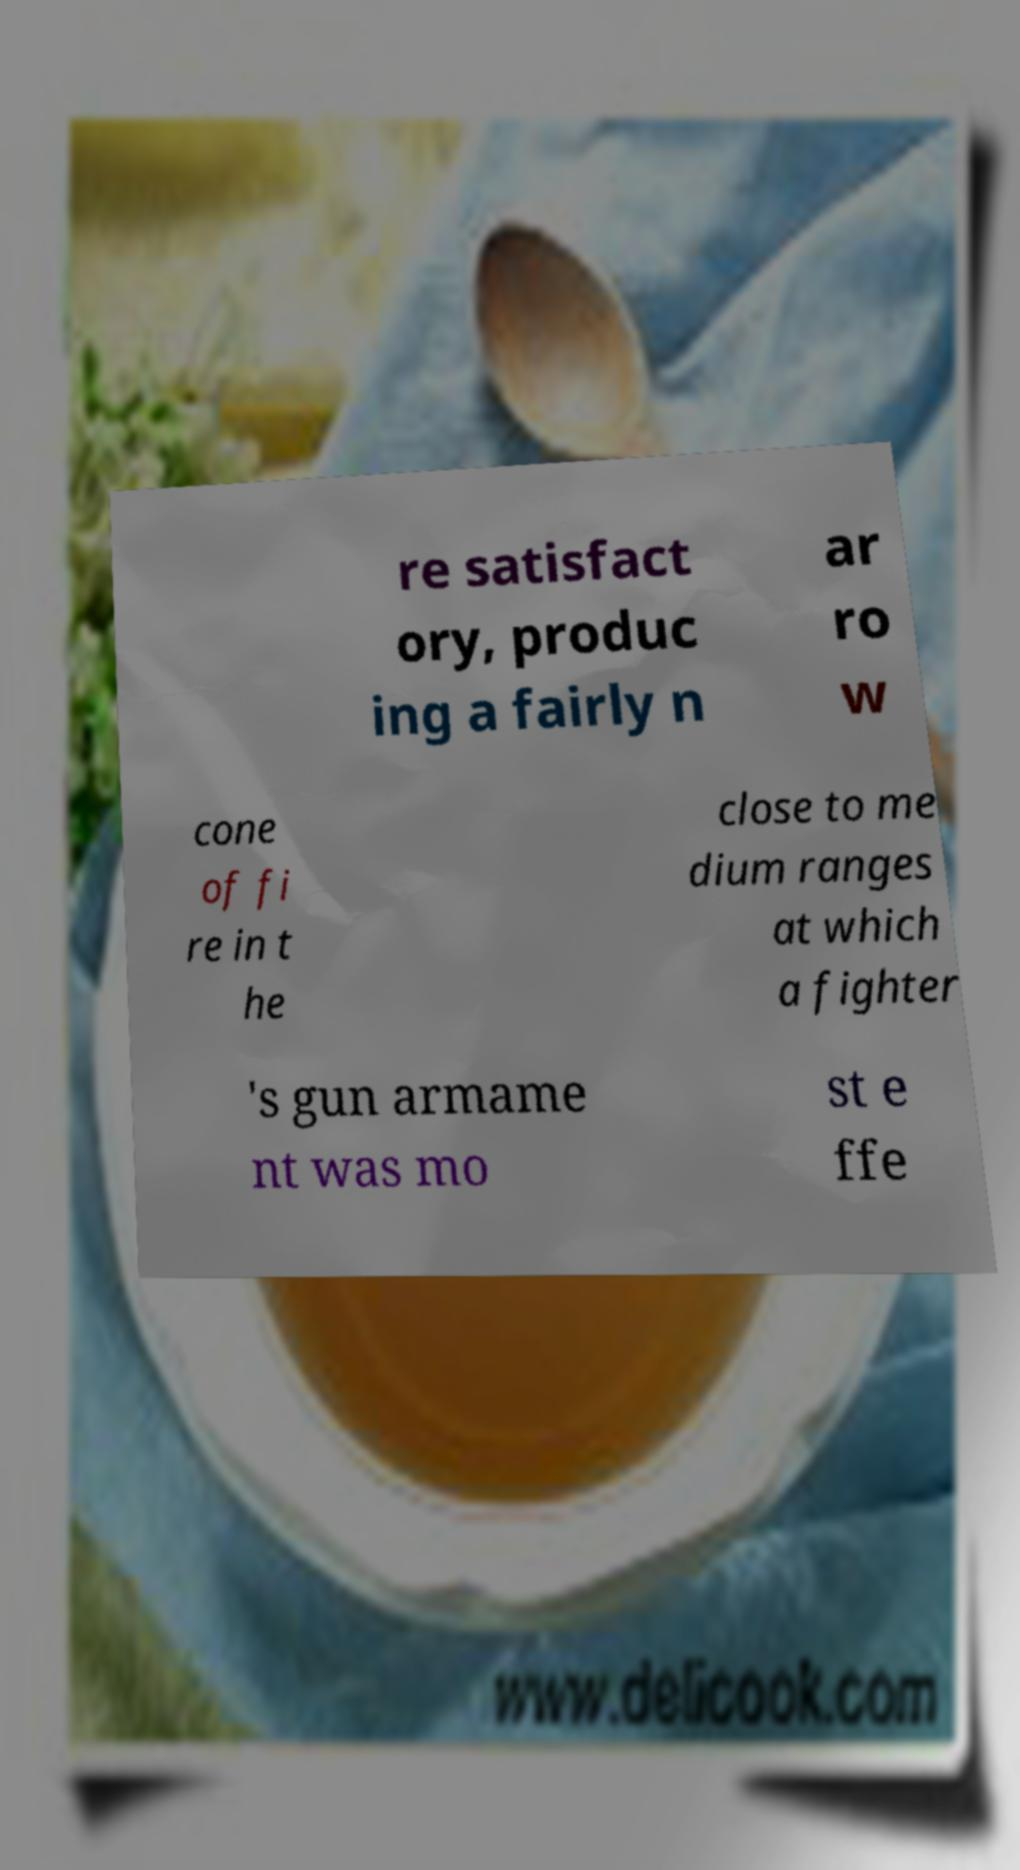Can you accurately transcribe the text from the provided image for me? re satisfact ory, produc ing a fairly n ar ro w cone of fi re in t he close to me dium ranges at which a fighter 's gun armame nt was mo st e ffe 